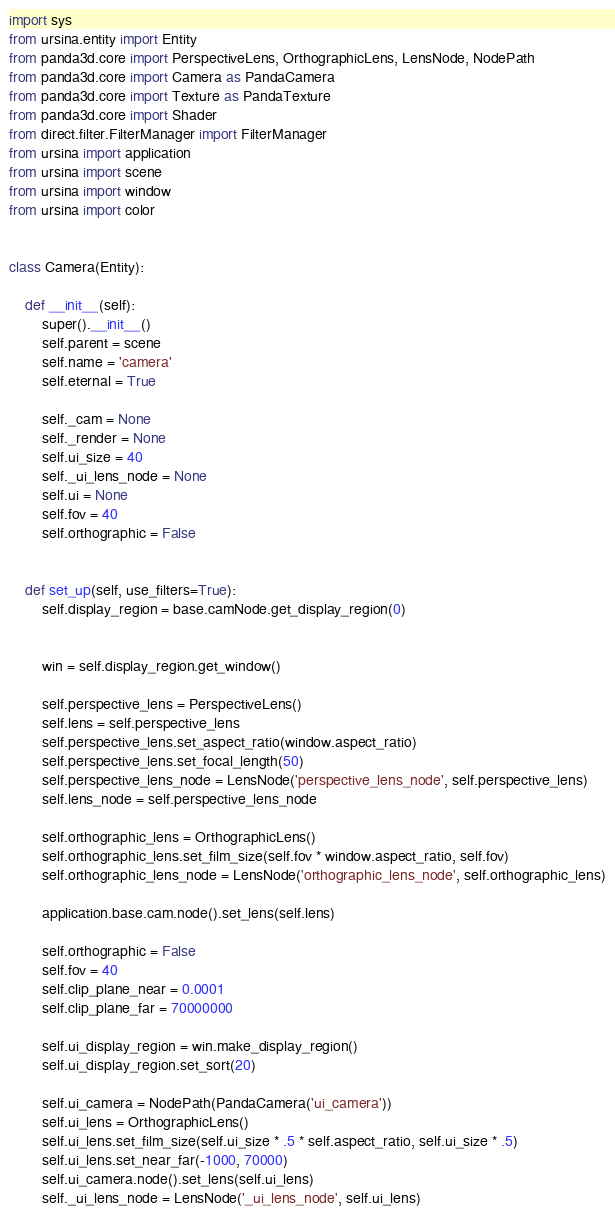Convert code to text. <code><loc_0><loc_0><loc_500><loc_500><_Python_>import sys
from ursina.entity import Entity
from panda3d.core import PerspectiveLens, OrthographicLens, LensNode, NodePath
from panda3d.core import Camera as PandaCamera
from panda3d.core import Texture as PandaTexture
from panda3d.core import Shader
from direct.filter.FilterManager import FilterManager
from ursina import application
from ursina import scene
from ursina import window
from ursina import color


class Camera(Entity):

    def __init__(self):
        super().__init__()
        self.parent = scene
        self.name = 'camera'
        self.eternal = True

        self._cam = None
        self._render = None
        self.ui_size = 40
        self._ui_lens_node = None
        self.ui = None
        self.fov = 40
        self.orthographic = False


    def set_up(self, use_filters=True):
        self.display_region = base.camNode.get_display_region(0)
        

        win = self.display_region.get_window()

        self.perspective_lens = PerspectiveLens()
        self.lens = self.perspective_lens
        self.perspective_lens.set_aspect_ratio(window.aspect_ratio)
        self.perspective_lens.set_focal_length(50)
        self.perspective_lens_node = LensNode('perspective_lens_node', self.perspective_lens)
        self.lens_node = self.perspective_lens_node

        self.orthographic_lens = OrthographicLens()
        self.orthographic_lens.set_film_size(self.fov * window.aspect_ratio, self.fov)
        self.orthographic_lens_node = LensNode('orthographic_lens_node', self.orthographic_lens)

        application.base.cam.node().set_lens(self.lens)

        self.orthographic = False
        self.fov = 40
        self.clip_plane_near = 0.0001
        self.clip_plane_far = 70000000

        self.ui_display_region = win.make_display_region()
        self.ui_display_region.set_sort(20)

        self.ui_camera = NodePath(PandaCamera('ui_camera'))
        self.ui_lens = OrthographicLens()
        self.ui_lens.set_film_size(self.ui_size * .5 * self.aspect_ratio, self.ui_size * .5)
        self.ui_lens.set_near_far(-1000, 70000)
        self.ui_camera.node().set_lens(self.ui_lens)
        self._ui_lens_node = LensNode('_ui_lens_node', self.ui_lens)
</code> 